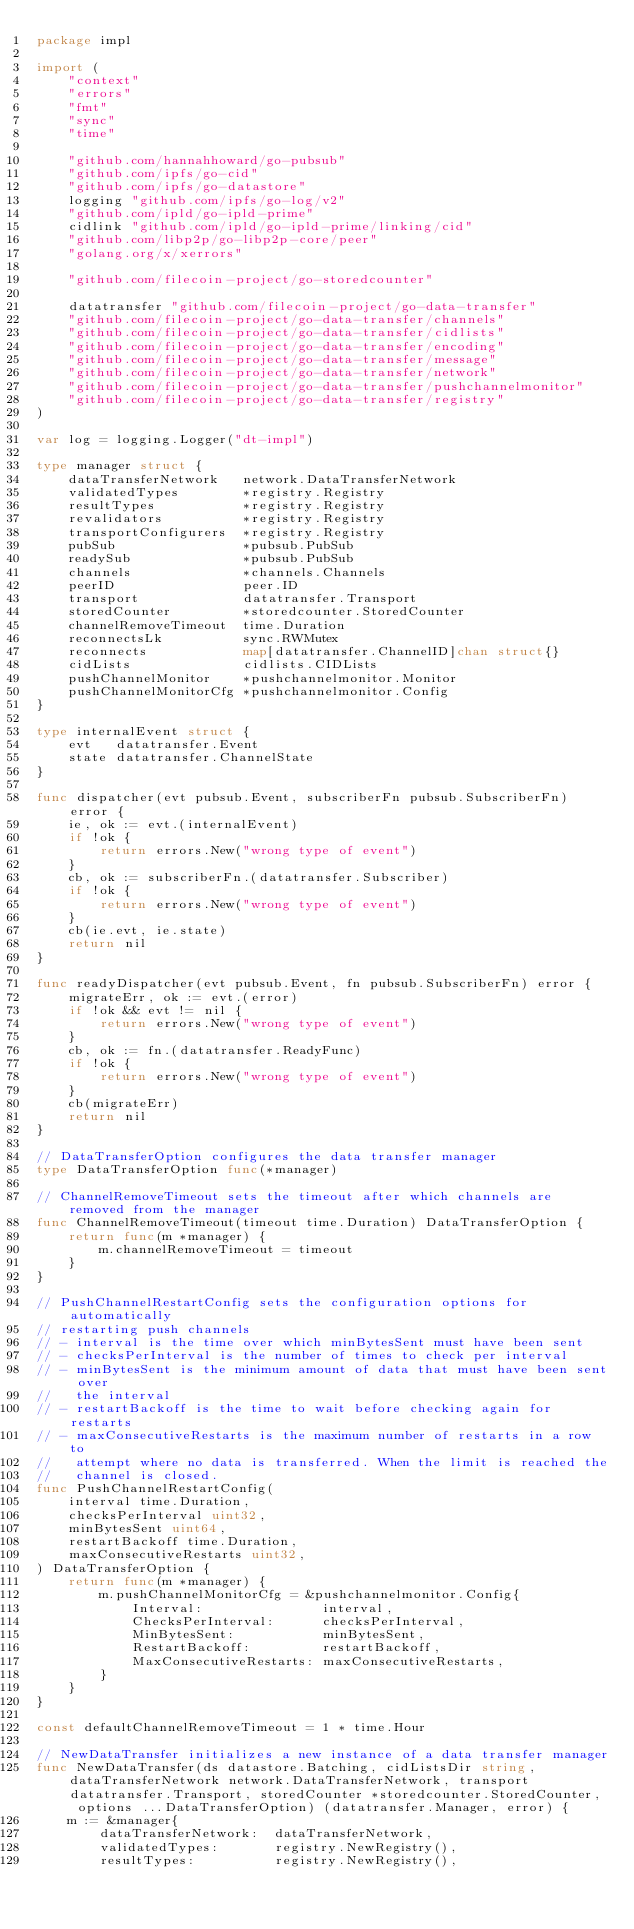<code> <loc_0><loc_0><loc_500><loc_500><_Go_>package impl

import (
	"context"
	"errors"
	"fmt"
	"sync"
	"time"

	"github.com/hannahhoward/go-pubsub"
	"github.com/ipfs/go-cid"
	"github.com/ipfs/go-datastore"
	logging "github.com/ipfs/go-log/v2"
	"github.com/ipld/go-ipld-prime"
	cidlink "github.com/ipld/go-ipld-prime/linking/cid"
	"github.com/libp2p/go-libp2p-core/peer"
	"golang.org/x/xerrors"

	"github.com/filecoin-project/go-storedcounter"

	datatransfer "github.com/filecoin-project/go-data-transfer"
	"github.com/filecoin-project/go-data-transfer/channels"
	"github.com/filecoin-project/go-data-transfer/cidlists"
	"github.com/filecoin-project/go-data-transfer/encoding"
	"github.com/filecoin-project/go-data-transfer/message"
	"github.com/filecoin-project/go-data-transfer/network"
	"github.com/filecoin-project/go-data-transfer/pushchannelmonitor"
	"github.com/filecoin-project/go-data-transfer/registry"
)

var log = logging.Logger("dt-impl")

type manager struct {
	dataTransferNetwork   network.DataTransferNetwork
	validatedTypes        *registry.Registry
	resultTypes           *registry.Registry
	revalidators          *registry.Registry
	transportConfigurers  *registry.Registry
	pubSub                *pubsub.PubSub
	readySub              *pubsub.PubSub
	channels              *channels.Channels
	peerID                peer.ID
	transport             datatransfer.Transport
	storedCounter         *storedcounter.StoredCounter
	channelRemoveTimeout  time.Duration
	reconnectsLk          sync.RWMutex
	reconnects            map[datatransfer.ChannelID]chan struct{}
	cidLists              cidlists.CIDLists
	pushChannelMonitor    *pushchannelmonitor.Monitor
	pushChannelMonitorCfg *pushchannelmonitor.Config
}

type internalEvent struct {
	evt   datatransfer.Event
	state datatransfer.ChannelState
}

func dispatcher(evt pubsub.Event, subscriberFn pubsub.SubscriberFn) error {
	ie, ok := evt.(internalEvent)
	if !ok {
		return errors.New("wrong type of event")
	}
	cb, ok := subscriberFn.(datatransfer.Subscriber)
	if !ok {
		return errors.New("wrong type of event")
	}
	cb(ie.evt, ie.state)
	return nil
}

func readyDispatcher(evt pubsub.Event, fn pubsub.SubscriberFn) error {
	migrateErr, ok := evt.(error)
	if !ok && evt != nil {
		return errors.New("wrong type of event")
	}
	cb, ok := fn.(datatransfer.ReadyFunc)
	if !ok {
		return errors.New("wrong type of event")
	}
	cb(migrateErr)
	return nil
}

// DataTransferOption configures the data transfer manager
type DataTransferOption func(*manager)

// ChannelRemoveTimeout sets the timeout after which channels are removed from the manager
func ChannelRemoveTimeout(timeout time.Duration) DataTransferOption {
	return func(m *manager) {
		m.channelRemoveTimeout = timeout
	}
}

// PushChannelRestartConfig sets the configuration options for automatically
// restarting push channels
// - interval is the time over which minBytesSent must have been sent
// - checksPerInterval is the number of times to check per interval
// - minBytesSent is the minimum amount of data that must have been sent over
//   the interval
// - restartBackoff is the time to wait before checking again for restarts
// - maxConsecutiveRestarts is the maximum number of restarts in a row to
//   attempt where no data is transferred. When the limit is reached the
//   channel is closed.
func PushChannelRestartConfig(
	interval time.Duration,
	checksPerInterval uint32,
	minBytesSent uint64,
	restartBackoff time.Duration,
	maxConsecutiveRestarts uint32,
) DataTransferOption {
	return func(m *manager) {
		m.pushChannelMonitorCfg = &pushchannelmonitor.Config{
			Interval:               interval,
			ChecksPerInterval:      checksPerInterval,
			MinBytesSent:           minBytesSent,
			RestartBackoff:         restartBackoff,
			MaxConsecutiveRestarts: maxConsecutiveRestarts,
		}
	}
}

const defaultChannelRemoveTimeout = 1 * time.Hour

// NewDataTransfer initializes a new instance of a data transfer manager
func NewDataTransfer(ds datastore.Batching, cidListsDir string, dataTransferNetwork network.DataTransferNetwork, transport datatransfer.Transport, storedCounter *storedcounter.StoredCounter, options ...DataTransferOption) (datatransfer.Manager, error) {
	m := &manager{
		dataTransferNetwork:  dataTransferNetwork,
		validatedTypes:       registry.NewRegistry(),
		resultTypes:          registry.NewRegistry(),</code> 